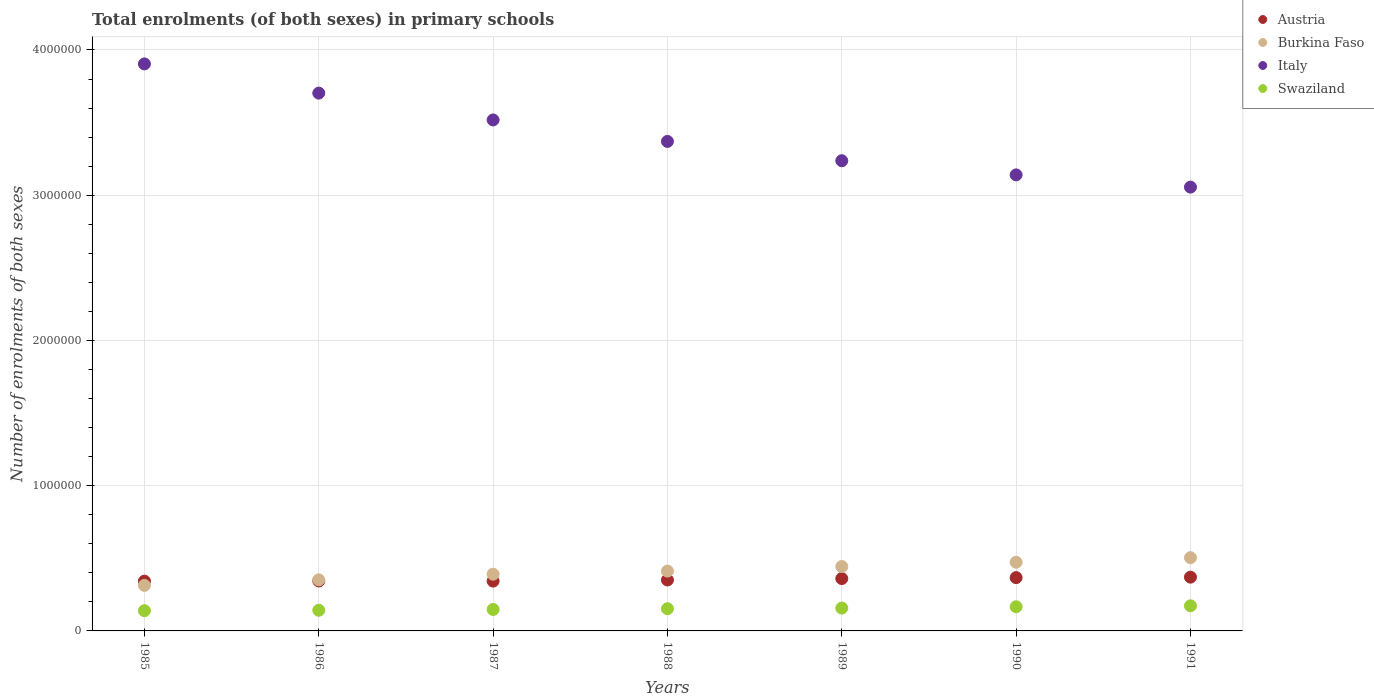Is the number of dotlines equal to the number of legend labels?
Your response must be concise. Yes. What is the number of enrolments in primary schools in Swaziland in 1986?
Make the answer very short. 1.42e+05. Across all years, what is the maximum number of enrolments in primary schools in Italy?
Your answer should be compact. 3.90e+06. Across all years, what is the minimum number of enrolments in primary schools in Swaziland?
Offer a very short reply. 1.39e+05. In which year was the number of enrolments in primary schools in Burkina Faso maximum?
Provide a short and direct response. 1991. What is the total number of enrolments in primary schools in Swaziland in the graph?
Provide a succinct answer. 1.08e+06. What is the difference between the number of enrolments in primary schools in Austria in 1989 and that in 1991?
Your response must be concise. -9668. What is the difference between the number of enrolments in primary schools in Swaziland in 1989 and the number of enrolments in primary schools in Italy in 1990?
Give a very brief answer. -2.98e+06. What is the average number of enrolments in primary schools in Italy per year?
Make the answer very short. 3.42e+06. In the year 1988, what is the difference between the number of enrolments in primary schools in Italy and number of enrolments in primary schools in Swaziland?
Provide a succinct answer. 3.22e+06. In how many years, is the number of enrolments in primary schools in Swaziland greater than 1600000?
Give a very brief answer. 0. What is the ratio of the number of enrolments in primary schools in Swaziland in 1986 to that in 1990?
Provide a short and direct response. 0.85. Is the number of enrolments in primary schools in Italy in 1986 less than that in 1988?
Your answer should be very brief. No. Is the difference between the number of enrolments in primary schools in Italy in 1985 and 1989 greater than the difference between the number of enrolments in primary schools in Swaziland in 1985 and 1989?
Provide a succinct answer. Yes. What is the difference between the highest and the second highest number of enrolments in primary schools in Italy?
Provide a succinct answer. 2.01e+05. What is the difference between the highest and the lowest number of enrolments in primary schools in Burkina Faso?
Your answer should be very brief. 1.91e+05. In how many years, is the number of enrolments in primary schools in Italy greater than the average number of enrolments in primary schools in Italy taken over all years?
Your response must be concise. 3. Is the number of enrolments in primary schools in Burkina Faso strictly greater than the number of enrolments in primary schools in Swaziland over the years?
Provide a succinct answer. Yes. Is the number of enrolments in primary schools in Italy strictly less than the number of enrolments in primary schools in Burkina Faso over the years?
Make the answer very short. No. Are the values on the major ticks of Y-axis written in scientific E-notation?
Make the answer very short. No. Does the graph contain grids?
Your answer should be compact. Yes. What is the title of the graph?
Your answer should be very brief. Total enrolments (of both sexes) in primary schools. What is the label or title of the X-axis?
Offer a very short reply. Years. What is the label or title of the Y-axis?
Provide a short and direct response. Number of enrolments of both sexes. What is the Number of enrolments of both sexes of Austria in 1985?
Keep it short and to the point. 3.43e+05. What is the Number of enrolments of both sexes of Burkina Faso in 1985?
Provide a succinct answer. 3.14e+05. What is the Number of enrolments of both sexes in Italy in 1985?
Provide a short and direct response. 3.90e+06. What is the Number of enrolments of both sexes in Swaziland in 1985?
Your answer should be compact. 1.39e+05. What is the Number of enrolments of both sexes of Austria in 1986?
Ensure brevity in your answer.  3.44e+05. What is the Number of enrolments of both sexes of Burkina Faso in 1986?
Give a very brief answer. 3.52e+05. What is the Number of enrolments of both sexes in Italy in 1986?
Offer a very short reply. 3.70e+06. What is the Number of enrolments of both sexes in Swaziland in 1986?
Your answer should be compact. 1.42e+05. What is the Number of enrolments of both sexes in Austria in 1987?
Keep it short and to the point. 3.43e+05. What is the Number of enrolments of both sexes in Burkina Faso in 1987?
Provide a short and direct response. 3.90e+05. What is the Number of enrolments of both sexes in Italy in 1987?
Provide a succinct answer. 3.52e+06. What is the Number of enrolments of both sexes of Swaziland in 1987?
Keep it short and to the point. 1.48e+05. What is the Number of enrolments of both sexes in Austria in 1988?
Your answer should be compact. 3.51e+05. What is the Number of enrolments of both sexes in Burkina Faso in 1988?
Your answer should be very brief. 4.12e+05. What is the Number of enrolments of both sexes of Italy in 1988?
Your answer should be very brief. 3.37e+06. What is the Number of enrolments of both sexes in Swaziland in 1988?
Keep it short and to the point. 1.53e+05. What is the Number of enrolments of both sexes of Austria in 1989?
Your response must be concise. 3.61e+05. What is the Number of enrolments of both sexes in Burkina Faso in 1989?
Offer a very short reply. 4.43e+05. What is the Number of enrolments of both sexes of Italy in 1989?
Provide a succinct answer. 3.24e+06. What is the Number of enrolments of both sexes of Swaziland in 1989?
Give a very brief answer. 1.57e+05. What is the Number of enrolments of both sexes in Austria in 1990?
Provide a short and direct response. 3.67e+05. What is the Number of enrolments of both sexes in Burkina Faso in 1990?
Provide a short and direct response. 4.73e+05. What is the Number of enrolments of both sexes of Italy in 1990?
Your answer should be very brief. 3.14e+06. What is the Number of enrolments of both sexes in Swaziland in 1990?
Ensure brevity in your answer.  1.66e+05. What is the Number of enrolments of both sexes in Austria in 1991?
Keep it short and to the point. 3.70e+05. What is the Number of enrolments of both sexes in Burkina Faso in 1991?
Provide a succinct answer. 5.04e+05. What is the Number of enrolments of both sexes of Italy in 1991?
Your answer should be compact. 3.06e+06. What is the Number of enrolments of both sexes of Swaziland in 1991?
Give a very brief answer. 1.73e+05. Across all years, what is the maximum Number of enrolments of both sexes in Austria?
Your answer should be very brief. 3.70e+05. Across all years, what is the maximum Number of enrolments of both sexes of Burkina Faso?
Make the answer very short. 5.04e+05. Across all years, what is the maximum Number of enrolments of both sexes of Italy?
Make the answer very short. 3.90e+06. Across all years, what is the maximum Number of enrolments of both sexes in Swaziland?
Provide a short and direct response. 1.73e+05. Across all years, what is the minimum Number of enrolments of both sexes in Austria?
Make the answer very short. 3.43e+05. Across all years, what is the minimum Number of enrolments of both sexes of Burkina Faso?
Make the answer very short. 3.14e+05. Across all years, what is the minimum Number of enrolments of both sexes in Italy?
Your answer should be very brief. 3.06e+06. Across all years, what is the minimum Number of enrolments of both sexes of Swaziland?
Make the answer very short. 1.39e+05. What is the total Number of enrolments of both sexes of Austria in the graph?
Give a very brief answer. 2.48e+06. What is the total Number of enrolments of both sexes in Burkina Faso in the graph?
Provide a succinct answer. 2.89e+06. What is the total Number of enrolments of both sexes of Italy in the graph?
Your answer should be compact. 2.39e+07. What is the total Number of enrolments of both sexes in Swaziland in the graph?
Give a very brief answer. 1.08e+06. What is the difference between the Number of enrolments of both sexes in Austria in 1985 and that in 1986?
Make the answer very short. -1044. What is the difference between the Number of enrolments of both sexes of Burkina Faso in 1985 and that in 1986?
Keep it short and to the point. -3.83e+04. What is the difference between the Number of enrolments of both sexes of Italy in 1985 and that in 1986?
Your response must be concise. 2.01e+05. What is the difference between the Number of enrolments of both sexes in Swaziland in 1985 and that in 1986?
Provide a short and direct response. -2861. What is the difference between the Number of enrolments of both sexes of Austria in 1985 and that in 1987?
Your response must be concise. -234. What is the difference between the Number of enrolments of both sexes in Burkina Faso in 1985 and that in 1987?
Your answer should be compact. -7.69e+04. What is the difference between the Number of enrolments of both sexes in Italy in 1985 and that in 1987?
Your response must be concise. 3.86e+05. What is the difference between the Number of enrolments of both sexes in Swaziland in 1985 and that in 1987?
Offer a terse response. -8398. What is the difference between the Number of enrolments of both sexes in Austria in 1985 and that in 1988?
Offer a very short reply. -7955. What is the difference between the Number of enrolments of both sexes of Burkina Faso in 1985 and that in 1988?
Provide a short and direct response. -9.84e+04. What is the difference between the Number of enrolments of both sexes of Italy in 1985 and that in 1988?
Give a very brief answer. 5.34e+05. What is the difference between the Number of enrolments of both sexes of Swaziland in 1985 and that in 1988?
Keep it short and to the point. -1.36e+04. What is the difference between the Number of enrolments of both sexes of Austria in 1985 and that in 1989?
Keep it short and to the point. -1.78e+04. What is the difference between the Number of enrolments of both sexes in Burkina Faso in 1985 and that in 1989?
Ensure brevity in your answer.  -1.30e+05. What is the difference between the Number of enrolments of both sexes in Italy in 1985 and that in 1989?
Make the answer very short. 6.67e+05. What is the difference between the Number of enrolments of both sexes in Swaziland in 1985 and that in 1989?
Your answer should be very brief. -1.80e+04. What is the difference between the Number of enrolments of both sexes of Austria in 1985 and that in 1990?
Your answer should be very brief. -2.42e+04. What is the difference between the Number of enrolments of both sexes in Burkina Faso in 1985 and that in 1990?
Offer a terse response. -1.59e+05. What is the difference between the Number of enrolments of both sexes in Italy in 1985 and that in 1990?
Keep it short and to the point. 7.64e+05. What is the difference between the Number of enrolments of both sexes of Swaziland in 1985 and that in 1990?
Your answer should be compact. -2.71e+04. What is the difference between the Number of enrolments of both sexes of Austria in 1985 and that in 1991?
Your answer should be compact. -2.74e+04. What is the difference between the Number of enrolments of both sexes in Burkina Faso in 1985 and that in 1991?
Ensure brevity in your answer.  -1.91e+05. What is the difference between the Number of enrolments of both sexes in Italy in 1985 and that in 1991?
Offer a terse response. 8.48e+05. What is the difference between the Number of enrolments of both sexes of Swaziland in 1985 and that in 1991?
Give a very brief answer. -3.36e+04. What is the difference between the Number of enrolments of both sexes of Austria in 1986 and that in 1987?
Your answer should be very brief. 810. What is the difference between the Number of enrolments of both sexes of Burkina Faso in 1986 and that in 1987?
Ensure brevity in your answer.  -3.86e+04. What is the difference between the Number of enrolments of both sexes in Italy in 1986 and that in 1987?
Your response must be concise. 1.85e+05. What is the difference between the Number of enrolments of both sexes of Swaziland in 1986 and that in 1987?
Your answer should be very brief. -5537. What is the difference between the Number of enrolments of both sexes of Austria in 1986 and that in 1988?
Make the answer very short. -6911. What is the difference between the Number of enrolments of both sexes in Burkina Faso in 1986 and that in 1988?
Your answer should be very brief. -6.01e+04. What is the difference between the Number of enrolments of both sexes in Italy in 1986 and that in 1988?
Make the answer very short. 3.33e+05. What is the difference between the Number of enrolments of both sexes in Swaziland in 1986 and that in 1988?
Keep it short and to the point. -1.07e+04. What is the difference between the Number of enrolments of both sexes in Austria in 1986 and that in 1989?
Offer a very short reply. -1.67e+04. What is the difference between the Number of enrolments of both sexes of Burkina Faso in 1986 and that in 1989?
Make the answer very short. -9.15e+04. What is the difference between the Number of enrolments of both sexes in Italy in 1986 and that in 1989?
Keep it short and to the point. 4.66e+05. What is the difference between the Number of enrolments of both sexes of Swaziland in 1986 and that in 1989?
Your answer should be compact. -1.51e+04. What is the difference between the Number of enrolments of both sexes in Austria in 1986 and that in 1990?
Offer a very short reply. -2.32e+04. What is the difference between the Number of enrolments of both sexes in Burkina Faso in 1986 and that in 1990?
Offer a very short reply. -1.21e+05. What is the difference between the Number of enrolments of both sexes in Italy in 1986 and that in 1990?
Make the answer very short. 5.63e+05. What is the difference between the Number of enrolments of both sexes of Swaziland in 1986 and that in 1990?
Give a very brief answer. -2.42e+04. What is the difference between the Number of enrolments of both sexes of Austria in 1986 and that in 1991?
Your answer should be compact. -2.64e+04. What is the difference between the Number of enrolments of both sexes of Burkina Faso in 1986 and that in 1991?
Your response must be concise. -1.53e+05. What is the difference between the Number of enrolments of both sexes in Italy in 1986 and that in 1991?
Your answer should be compact. 6.47e+05. What is the difference between the Number of enrolments of both sexes in Swaziland in 1986 and that in 1991?
Give a very brief answer. -3.07e+04. What is the difference between the Number of enrolments of both sexes of Austria in 1987 and that in 1988?
Your response must be concise. -7721. What is the difference between the Number of enrolments of both sexes of Burkina Faso in 1987 and that in 1988?
Your answer should be very brief. -2.15e+04. What is the difference between the Number of enrolments of both sexes of Italy in 1987 and that in 1988?
Give a very brief answer. 1.48e+05. What is the difference between the Number of enrolments of both sexes in Swaziland in 1987 and that in 1988?
Provide a short and direct response. -5152. What is the difference between the Number of enrolments of both sexes of Austria in 1987 and that in 1989?
Keep it short and to the point. -1.75e+04. What is the difference between the Number of enrolments of both sexes of Burkina Faso in 1987 and that in 1989?
Provide a succinct answer. -5.29e+04. What is the difference between the Number of enrolments of both sexes in Italy in 1987 and that in 1989?
Provide a short and direct response. 2.81e+05. What is the difference between the Number of enrolments of both sexes of Swaziland in 1987 and that in 1989?
Provide a short and direct response. -9602. What is the difference between the Number of enrolments of both sexes of Austria in 1987 and that in 1990?
Offer a very short reply. -2.40e+04. What is the difference between the Number of enrolments of both sexes of Burkina Faso in 1987 and that in 1990?
Make the answer very short. -8.26e+04. What is the difference between the Number of enrolments of both sexes in Italy in 1987 and that in 1990?
Provide a short and direct response. 3.78e+05. What is the difference between the Number of enrolments of both sexes of Swaziland in 1987 and that in 1990?
Offer a very short reply. -1.87e+04. What is the difference between the Number of enrolments of both sexes in Austria in 1987 and that in 1991?
Provide a succinct answer. -2.72e+04. What is the difference between the Number of enrolments of both sexes of Burkina Faso in 1987 and that in 1991?
Keep it short and to the point. -1.14e+05. What is the difference between the Number of enrolments of both sexes of Italy in 1987 and that in 1991?
Your response must be concise. 4.62e+05. What is the difference between the Number of enrolments of both sexes of Swaziland in 1987 and that in 1991?
Give a very brief answer. -2.52e+04. What is the difference between the Number of enrolments of both sexes in Austria in 1988 and that in 1989?
Provide a succinct answer. -9808. What is the difference between the Number of enrolments of both sexes in Burkina Faso in 1988 and that in 1989?
Your answer should be compact. -3.14e+04. What is the difference between the Number of enrolments of both sexes in Italy in 1988 and that in 1989?
Offer a very short reply. 1.33e+05. What is the difference between the Number of enrolments of both sexes of Swaziland in 1988 and that in 1989?
Make the answer very short. -4450. What is the difference between the Number of enrolments of both sexes of Austria in 1988 and that in 1990?
Make the answer very short. -1.63e+04. What is the difference between the Number of enrolments of both sexes of Burkina Faso in 1988 and that in 1990?
Give a very brief answer. -6.11e+04. What is the difference between the Number of enrolments of both sexes in Italy in 1988 and that in 1990?
Provide a short and direct response. 2.30e+05. What is the difference between the Number of enrolments of both sexes in Swaziland in 1988 and that in 1990?
Provide a succinct answer. -1.36e+04. What is the difference between the Number of enrolments of both sexes in Austria in 1988 and that in 1991?
Keep it short and to the point. -1.95e+04. What is the difference between the Number of enrolments of both sexes of Burkina Faso in 1988 and that in 1991?
Your answer should be compact. -9.25e+04. What is the difference between the Number of enrolments of both sexes in Italy in 1988 and that in 1991?
Your answer should be very brief. 3.15e+05. What is the difference between the Number of enrolments of both sexes of Swaziland in 1988 and that in 1991?
Provide a short and direct response. -2.00e+04. What is the difference between the Number of enrolments of both sexes of Austria in 1989 and that in 1990?
Offer a very short reply. -6464. What is the difference between the Number of enrolments of both sexes of Burkina Faso in 1989 and that in 1990?
Offer a very short reply. -2.97e+04. What is the difference between the Number of enrolments of both sexes of Italy in 1989 and that in 1990?
Provide a succinct answer. 9.75e+04. What is the difference between the Number of enrolments of both sexes of Swaziland in 1989 and that in 1990?
Your answer should be very brief. -9109. What is the difference between the Number of enrolments of both sexes of Austria in 1989 and that in 1991?
Keep it short and to the point. -9668. What is the difference between the Number of enrolments of both sexes in Burkina Faso in 1989 and that in 1991?
Give a very brief answer. -6.11e+04. What is the difference between the Number of enrolments of both sexes in Italy in 1989 and that in 1991?
Your answer should be compact. 1.82e+05. What is the difference between the Number of enrolments of both sexes of Swaziland in 1989 and that in 1991?
Ensure brevity in your answer.  -1.56e+04. What is the difference between the Number of enrolments of both sexes in Austria in 1990 and that in 1991?
Offer a terse response. -3204. What is the difference between the Number of enrolments of both sexes of Burkina Faso in 1990 and that in 1991?
Offer a terse response. -3.14e+04. What is the difference between the Number of enrolments of both sexes of Italy in 1990 and that in 1991?
Ensure brevity in your answer.  8.42e+04. What is the difference between the Number of enrolments of both sexes of Swaziland in 1990 and that in 1991?
Keep it short and to the point. -6454. What is the difference between the Number of enrolments of both sexes of Austria in 1985 and the Number of enrolments of both sexes of Burkina Faso in 1986?
Your response must be concise. -9028. What is the difference between the Number of enrolments of both sexes of Austria in 1985 and the Number of enrolments of both sexes of Italy in 1986?
Give a very brief answer. -3.36e+06. What is the difference between the Number of enrolments of both sexes in Austria in 1985 and the Number of enrolments of both sexes in Swaziland in 1986?
Offer a terse response. 2.01e+05. What is the difference between the Number of enrolments of both sexes of Burkina Faso in 1985 and the Number of enrolments of both sexes of Italy in 1986?
Offer a very short reply. -3.39e+06. What is the difference between the Number of enrolments of both sexes of Burkina Faso in 1985 and the Number of enrolments of both sexes of Swaziland in 1986?
Provide a succinct answer. 1.71e+05. What is the difference between the Number of enrolments of both sexes in Italy in 1985 and the Number of enrolments of both sexes in Swaziland in 1986?
Your response must be concise. 3.76e+06. What is the difference between the Number of enrolments of both sexes of Austria in 1985 and the Number of enrolments of both sexes of Burkina Faso in 1987?
Your response must be concise. -4.76e+04. What is the difference between the Number of enrolments of both sexes of Austria in 1985 and the Number of enrolments of both sexes of Italy in 1987?
Your response must be concise. -3.18e+06. What is the difference between the Number of enrolments of both sexes in Austria in 1985 and the Number of enrolments of both sexes in Swaziland in 1987?
Give a very brief answer. 1.95e+05. What is the difference between the Number of enrolments of both sexes in Burkina Faso in 1985 and the Number of enrolments of both sexes in Italy in 1987?
Provide a short and direct response. -3.20e+06. What is the difference between the Number of enrolments of both sexes in Burkina Faso in 1985 and the Number of enrolments of both sexes in Swaziland in 1987?
Your answer should be compact. 1.66e+05. What is the difference between the Number of enrolments of both sexes in Italy in 1985 and the Number of enrolments of both sexes in Swaziland in 1987?
Your response must be concise. 3.76e+06. What is the difference between the Number of enrolments of both sexes of Austria in 1985 and the Number of enrolments of both sexes of Burkina Faso in 1988?
Your answer should be compact. -6.91e+04. What is the difference between the Number of enrolments of both sexes of Austria in 1985 and the Number of enrolments of both sexes of Italy in 1988?
Offer a very short reply. -3.03e+06. What is the difference between the Number of enrolments of both sexes in Austria in 1985 and the Number of enrolments of both sexes in Swaziland in 1988?
Offer a very short reply. 1.90e+05. What is the difference between the Number of enrolments of both sexes in Burkina Faso in 1985 and the Number of enrolments of both sexes in Italy in 1988?
Give a very brief answer. -3.06e+06. What is the difference between the Number of enrolments of both sexes in Burkina Faso in 1985 and the Number of enrolments of both sexes in Swaziland in 1988?
Provide a short and direct response. 1.61e+05. What is the difference between the Number of enrolments of both sexes in Italy in 1985 and the Number of enrolments of both sexes in Swaziland in 1988?
Offer a terse response. 3.75e+06. What is the difference between the Number of enrolments of both sexes of Austria in 1985 and the Number of enrolments of both sexes of Burkina Faso in 1989?
Give a very brief answer. -1.01e+05. What is the difference between the Number of enrolments of both sexes in Austria in 1985 and the Number of enrolments of both sexes in Italy in 1989?
Offer a terse response. -2.89e+06. What is the difference between the Number of enrolments of both sexes in Austria in 1985 and the Number of enrolments of both sexes in Swaziland in 1989?
Offer a very short reply. 1.85e+05. What is the difference between the Number of enrolments of both sexes of Burkina Faso in 1985 and the Number of enrolments of both sexes of Italy in 1989?
Provide a succinct answer. -2.92e+06. What is the difference between the Number of enrolments of both sexes of Burkina Faso in 1985 and the Number of enrolments of both sexes of Swaziland in 1989?
Provide a short and direct response. 1.56e+05. What is the difference between the Number of enrolments of both sexes of Italy in 1985 and the Number of enrolments of both sexes of Swaziland in 1989?
Give a very brief answer. 3.75e+06. What is the difference between the Number of enrolments of both sexes in Austria in 1985 and the Number of enrolments of both sexes in Burkina Faso in 1990?
Your answer should be very brief. -1.30e+05. What is the difference between the Number of enrolments of both sexes in Austria in 1985 and the Number of enrolments of both sexes in Italy in 1990?
Ensure brevity in your answer.  -2.80e+06. What is the difference between the Number of enrolments of both sexes in Austria in 1985 and the Number of enrolments of both sexes in Swaziland in 1990?
Keep it short and to the point. 1.76e+05. What is the difference between the Number of enrolments of both sexes of Burkina Faso in 1985 and the Number of enrolments of both sexes of Italy in 1990?
Keep it short and to the point. -2.83e+06. What is the difference between the Number of enrolments of both sexes in Burkina Faso in 1985 and the Number of enrolments of both sexes in Swaziland in 1990?
Your answer should be very brief. 1.47e+05. What is the difference between the Number of enrolments of both sexes in Italy in 1985 and the Number of enrolments of both sexes in Swaziland in 1990?
Provide a short and direct response. 3.74e+06. What is the difference between the Number of enrolments of both sexes in Austria in 1985 and the Number of enrolments of both sexes in Burkina Faso in 1991?
Your answer should be very brief. -1.62e+05. What is the difference between the Number of enrolments of both sexes in Austria in 1985 and the Number of enrolments of both sexes in Italy in 1991?
Give a very brief answer. -2.71e+06. What is the difference between the Number of enrolments of both sexes of Austria in 1985 and the Number of enrolments of both sexes of Swaziland in 1991?
Keep it short and to the point. 1.70e+05. What is the difference between the Number of enrolments of both sexes of Burkina Faso in 1985 and the Number of enrolments of both sexes of Italy in 1991?
Ensure brevity in your answer.  -2.74e+06. What is the difference between the Number of enrolments of both sexes in Burkina Faso in 1985 and the Number of enrolments of both sexes in Swaziland in 1991?
Keep it short and to the point. 1.41e+05. What is the difference between the Number of enrolments of both sexes of Italy in 1985 and the Number of enrolments of both sexes of Swaziland in 1991?
Give a very brief answer. 3.73e+06. What is the difference between the Number of enrolments of both sexes of Austria in 1986 and the Number of enrolments of both sexes of Burkina Faso in 1987?
Ensure brevity in your answer.  -4.66e+04. What is the difference between the Number of enrolments of both sexes of Austria in 1986 and the Number of enrolments of both sexes of Italy in 1987?
Keep it short and to the point. -3.17e+06. What is the difference between the Number of enrolments of both sexes of Austria in 1986 and the Number of enrolments of both sexes of Swaziland in 1987?
Keep it short and to the point. 1.96e+05. What is the difference between the Number of enrolments of both sexes in Burkina Faso in 1986 and the Number of enrolments of both sexes in Italy in 1987?
Make the answer very short. -3.17e+06. What is the difference between the Number of enrolments of both sexes in Burkina Faso in 1986 and the Number of enrolments of both sexes in Swaziland in 1987?
Provide a short and direct response. 2.04e+05. What is the difference between the Number of enrolments of both sexes of Italy in 1986 and the Number of enrolments of both sexes of Swaziland in 1987?
Give a very brief answer. 3.56e+06. What is the difference between the Number of enrolments of both sexes in Austria in 1986 and the Number of enrolments of both sexes in Burkina Faso in 1988?
Ensure brevity in your answer.  -6.81e+04. What is the difference between the Number of enrolments of both sexes in Austria in 1986 and the Number of enrolments of both sexes in Italy in 1988?
Offer a terse response. -3.03e+06. What is the difference between the Number of enrolments of both sexes in Austria in 1986 and the Number of enrolments of both sexes in Swaziland in 1988?
Provide a short and direct response. 1.91e+05. What is the difference between the Number of enrolments of both sexes of Burkina Faso in 1986 and the Number of enrolments of both sexes of Italy in 1988?
Give a very brief answer. -3.02e+06. What is the difference between the Number of enrolments of both sexes in Burkina Faso in 1986 and the Number of enrolments of both sexes in Swaziland in 1988?
Keep it short and to the point. 1.99e+05. What is the difference between the Number of enrolments of both sexes in Italy in 1986 and the Number of enrolments of both sexes in Swaziland in 1988?
Give a very brief answer. 3.55e+06. What is the difference between the Number of enrolments of both sexes of Austria in 1986 and the Number of enrolments of both sexes of Burkina Faso in 1989?
Your response must be concise. -9.95e+04. What is the difference between the Number of enrolments of both sexes in Austria in 1986 and the Number of enrolments of both sexes in Italy in 1989?
Provide a short and direct response. -2.89e+06. What is the difference between the Number of enrolments of both sexes in Austria in 1986 and the Number of enrolments of both sexes in Swaziland in 1989?
Make the answer very short. 1.86e+05. What is the difference between the Number of enrolments of both sexes in Burkina Faso in 1986 and the Number of enrolments of both sexes in Italy in 1989?
Ensure brevity in your answer.  -2.89e+06. What is the difference between the Number of enrolments of both sexes in Burkina Faso in 1986 and the Number of enrolments of both sexes in Swaziland in 1989?
Offer a very short reply. 1.94e+05. What is the difference between the Number of enrolments of both sexes in Italy in 1986 and the Number of enrolments of both sexes in Swaziland in 1989?
Offer a very short reply. 3.55e+06. What is the difference between the Number of enrolments of both sexes of Austria in 1986 and the Number of enrolments of both sexes of Burkina Faso in 1990?
Give a very brief answer. -1.29e+05. What is the difference between the Number of enrolments of both sexes of Austria in 1986 and the Number of enrolments of both sexes of Italy in 1990?
Offer a terse response. -2.80e+06. What is the difference between the Number of enrolments of both sexes in Austria in 1986 and the Number of enrolments of both sexes in Swaziland in 1990?
Ensure brevity in your answer.  1.77e+05. What is the difference between the Number of enrolments of both sexes of Burkina Faso in 1986 and the Number of enrolments of both sexes of Italy in 1990?
Your answer should be compact. -2.79e+06. What is the difference between the Number of enrolments of both sexes in Burkina Faso in 1986 and the Number of enrolments of both sexes in Swaziland in 1990?
Offer a very short reply. 1.85e+05. What is the difference between the Number of enrolments of both sexes in Italy in 1986 and the Number of enrolments of both sexes in Swaziland in 1990?
Keep it short and to the point. 3.54e+06. What is the difference between the Number of enrolments of both sexes of Austria in 1986 and the Number of enrolments of both sexes of Burkina Faso in 1991?
Your answer should be very brief. -1.61e+05. What is the difference between the Number of enrolments of both sexes in Austria in 1986 and the Number of enrolments of both sexes in Italy in 1991?
Offer a terse response. -2.71e+06. What is the difference between the Number of enrolments of both sexes of Austria in 1986 and the Number of enrolments of both sexes of Swaziland in 1991?
Give a very brief answer. 1.71e+05. What is the difference between the Number of enrolments of both sexes in Burkina Faso in 1986 and the Number of enrolments of both sexes in Italy in 1991?
Provide a succinct answer. -2.70e+06. What is the difference between the Number of enrolments of both sexes in Burkina Faso in 1986 and the Number of enrolments of both sexes in Swaziland in 1991?
Ensure brevity in your answer.  1.79e+05. What is the difference between the Number of enrolments of both sexes of Italy in 1986 and the Number of enrolments of both sexes of Swaziland in 1991?
Provide a succinct answer. 3.53e+06. What is the difference between the Number of enrolments of both sexes of Austria in 1987 and the Number of enrolments of both sexes of Burkina Faso in 1988?
Ensure brevity in your answer.  -6.89e+04. What is the difference between the Number of enrolments of both sexes of Austria in 1987 and the Number of enrolments of both sexes of Italy in 1988?
Your response must be concise. -3.03e+06. What is the difference between the Number of enrolments of both sexes of Austria in 1987 and the Number of enrolments of both sexes of Swaziland in 1988?
Give a very brief answer. 1.90e+05. What is the difference between the Number of enrolments of both sexes of Burkina Faso in 1987 and the Number of enrolments of both sexes of Italy in 1988?
Give a very brief answer. -2.98e+06. What is the difference between the Number of enrolments of both sexes in Burkina Faso in 1987 and the Number of enrolments of both sexes in Swaziland in 1988?
Ensure brevity in your answer.  2.38e+05. What is the difference between the Number of enrolments of both sexes in Italy in 1987 and the Number of enrolments of both sexes in Swaziland in 1988?
Ensure brevity in your answer.  3.37e+06. What is the difference between the Number of enrolments of both sexes of Austria in 1987 and the Number of enrolments of both sexes of Burkina Faso in 1989?
Keep it short and to the point. -1.00e+05. What is the difference between the Number of enrolments of both sexes of Austria in 1987 and the Number of enrolments of both sexes of Italy in 1989?
Give a very brief answer. -2.89e+06. What is the difference between the Number of enrolments of both sexes in Austria in 1987 and the Number of enrolments of both sexes in Swaziland in 1989?
Your answer should be compact. 1.86e+05. What is the difference between the Number of enrolments of both sexes in Burkina Faso in 1987 and the Number of enrolments of both sexes in Italy in 1989?
Ensure brevity in your answer.  -2.85e+06. What is the difference between the Number of enrolments of both sexes in Burkina Faso in 1987 and the Number of enrolments of both sexes in Swaziland in 1989?
Provide a short and direct response. 2.33e+05. What is the difference between the Number of enrolments of both sexes of Italy in 1987 and the Number of enrolments of both sexes of Swaziland in 1989?
Make the answer very short. 3.36e+06. What is the difference between the Number of enrolments of both sexes of Austria in 1987 and the Number of enrolments of both sexes of Burkina Faso in 1990?
Your answer should be compact. -1.30e+05. What is the difference between the Number of enrolments of both sexes of Austria in 1987 and the Number of enrolments of both sexes of Italy in 1990?
Give a very brief answer. -2.80e+06. What is the difference between the Number of enrolments of both sexes in Austria in 1987 and the Number of enrolments of both sexes in Swaziland in 1990?
Your answer should be very brief. 1.77e+05. What is the difference between the Number of enrolments of both sexes of Burkina Faso in 1987 and the Number of enrolments of both sexes of Italy in 1990?
Make the answer very short. -2.75e+06. What is the difference between the Number of enrolments of both sexes in Burkina Faso in 1987 and the Number of enrolments of both sexes in Swaziland in 1990?
Ensure brevity in your answer.  2.24e+05. What is the difference between the Number of enrolments of both sexes in Italy in 1987 and the Number of enrolments of both sexes in Swaziland in 1990?
Your answer should be very brief. 3.35e+06. What is the difference between the Number of enrolments of both sexes of Austria in 1987 and the Number of enrolments of both sexes of Burkina Faso in 1991?
Offer a very short reply. -1.61e+05. What is the difference between the Number of enrolments of both sexes of Austria in 1987 and the Number of enrolments of both sexes of Italy in 1991?
Your answer should be very brief. -2.71e+06. What is the difference between the Number of enrolments of both sexes in Austria in 1987 and the Number of enrolments of both sexes in Swaziland in 1991?
Your answer should be compact. 1.70e+05. What is the difference between the Number of enrolments of both sexes of Burkina Faso in 1987 and the Number of enrolments of both sexes of Italy in 1991?
Your response must be concise. -2.67e+06. What is the difference between the Number of enrolments of both sexes of Burkina Faso in 1987 and the Number of enrolments of both sexes of Swaziland in 1991?
Your answer should be compact. 2.18e+05. What is the difference between the Number of enrolments of both sexes of Italy in 1987 and the Number of enrolments of both sexes of Swaziland in 1991?
Give a very brief answer. 3.35e+06. What is the difference between the Number of enrolments of both sexes in Austria in 1988 and the Number of enrolments of both sexes in Burkina Faso in 1989?
Your response must be concise. -9.26e+04. What is the difference between the Number of enrolments of both sexes of Austria in 1988 and the Number of enrolments of both sexes of Italy in 1989?
Make the answer very short. -2.89e+06. What is the difference between the Number of enrolments of both sexes in Austria in 1988 and the Number of enrolments of both sexes in Swaziland in 1989?
Your answer should be compact. 1.93e+05. What is the difference between the Number of enrolments of both sexes in Burkina Faso in 1988 and the Number of enrolments of both sexes in Italy in 1989?
Offer a very short reply. -2.83e+06. What is the difference between the Number of enrolments of both sexes of Burkina Faso in 1988 and the Number of enrolments of both sexes of Swaziland in 1989?
Offer a terse response. 2.55e+05. What is the difference between the Number of enrolments of both sexes of Italy in 1988 and the Number of enrolments of both sexes of Swaziland in 1989?
Ensure brevity in your answer.  3.21e+06. What is the difference between the Number of enrolments of both sexes in Austria in 1988 and the Number of enrolments of both sexes in Burkina Faso in 1990?
Keep it short and to the point. -1.22e+05. What is the difference between the Number of enrolments of both sexes of Austria in 1988 and the Number of enrolments of both sexes of Italy in 1990?
Give a very brief answer. -2.79e+06. What is the difference between the Number of enrolments of both sexes of Austria in 1988 and the Number of enrolments of both sexes of Swaziland in 1990?
Your response must be concise. 1.84e+05. What is the difference between the Number of enrolments of both sexes of Burkina Faso in 1988 and the Number of enrolments of both sexes of Italy in 1990?
Keep it short and to the point. -2.73e+06. What is the difference between the Number of enrolments of both sexes of Burkina Faso in 1988 and the Number of enrolments of both sexes of Swaziland in 1990?
Your answer should be very brief. 2.45e+05. What is the difference between the Number of enrolments of both sexes in Italy in 1988 and the Number of enrolments of both sexes in Swaziland in 1990?
Make the answer very short. 3.20e+06. What is the difference between the Number of enrolments of both sexes in Austria in 1988 and the Number of enrolments of both sexes in Burkina Faso in 1991?
Offer a terse response. -1.54e+05. What is the difference between the Number of enrolments of both sexes in Austria in 1988 and the Number of enrolments of both sexes in Italy in 1991?
Provide a short and direct response. -2.71e+06. What is the difference between the Number of enrolments of both sexes of Austria in 1988 and the Number of enrolments of both sexes of Swaziland in 1991?
Your answer should be very brief. 1.78e+05. What is the difference between the Number of enrolments of both sexes of Burkina Faso in 1988 and the Number of enrolments of both sexes of Italy in 1991?
Provide a short and direct response. -2.64e+06. What is the difference between the Number of enrolments of both sexes in Burkina Faso in 1988 and the Number of enrolments of both sexes in Swaziland in 1991?
Your answer should be compact. 2.39e+05. What is the difference between the Number of enrolments of both sexes in Italy in 1988 and the Number of enrolments of both sexes in Swaziland in 1991?
Your answer should be very brief. 3.20e+06. What is the difference between the Number of enrolments of both sexes of Austria in 1989 and the Number of enrolments of both sexes of Burkina Faso in 1990?
Give a very brief answer. -1.12e+05. What is the difference between the Number of enrolments of both sexes in Austria in 1989 and the Number of enrolments of both sexes in Italy in 1990?
Your response must be concise. -2.78e+06. What is the difference between the Number of enrolments of both sexes in Austria in 1989 and the Number of enrolments of both sexes in Swaziland in 1990?
Keep it short and to the point. 1.94e+05. What is the difference between the Number of enrolments of both sexes of Burkina Faso in 1989 and the Number of enrolments of both sexes of Italy in 1990?
Your answer should be compact. -2.70e+06. What is the difference between the Number of enrolments of both sexes in Burkina Faso in 1989 and the Number of enrolments of both sexes in Swaziland in 1990?
Offer a terse response. 2.77e+05. What is the difference between the Number of enrolments of both sexes of Italy in 1989 and the Number of enrolments of both sexes of Swaziland in 1990?
Offer a terse response. 3.07e+06. What is the difference between the Number of enrolments of both sexes in Austria in 1989 and the Number of enrolments of both sexes in Burkina Faso in 1991?
Your answer should be compact. -1.44e+05. What is the difference between the Number of enrolments of both sexes in Austria in 1989 and the Number of enrolments of both sexes in Italy in 1991?
Provide a succinct answer. -2.70e+06. What is the difference between the Number of enrolments of both sexes in Austria in 1989 and the Number of enrolments of both sexes in Swaziland in 1991?
Provide a succinct answer. 1.88e+05. What is the difference between the Number of enrolments of both sexes of Burkina Faso in 1989 and the Number of enrolments of both sexes of Italy in 1991?
Make the answer very short. -2.61e+06. What is the difference between the Number of enrolments of both sexes in Burkina Faso in 1989 and the Number of enrolments of both sexes in Swaziland in 1991?
Your answer should be very brief. 2.70e+05. What is the difference between the Number of enrolments of both sexes in Italy in 1989 and the Number of enrolments of both sexes in Swaziland in 1991?
Provide a short and direct response. 3.06e+06. What is the difference between the Number of enrolments of both sexes of Austria in 1990 and the Number of enrolments of both sexes of Burkina Faso in 1991?
Your answer should be very brief. -1.37e+05. What is the difference between the Number of enrolments of both sexes in Austria in 1990 and the Number of enrolments of both sexes in Italy in 1991?
Keep it short and to the point. -2.69e+06. What is the difference between the Number of enrolments of both sexes in Austria in 1990 and the Number of enrolments of both sexes in Swaziland in 1991?
Your response must be concise. 1.94e+05. What is the difference between the Number of enrolments of both sexes in Burkina Faso in 1990 and the Number of enrolments of both sexes in Italy in 1991?
Keep it short and to the point. -2.58e+06. What is the difference between the Number of enrolments of both sexes of Burkina Faso in 1990 and the Number of enrolments of both sexes of Swaziland in 1991?
Keep it short and to the point. 3.00e+05. What is the difference between the Number of enrolments of both sexes of Italy in 1990 and the Number of enrolments of both sexes of Swaziland in 1991?
Offer a very short reply. 2.97e+06. What is the average Number of enrolments of both sexes in Austria per year?
Keep it short and to the point. 3.54e+05. What is the average Number of enrolments of both sexes in Burkina Faso per year?
Ensure brevity in your answer.  4.13e+05. What is the average Number of enrolments of both sexes of Italy per year?
Provide a short and direct response. 3.42e+06. What is the average Number of enrolments of both sexes of Swaziland per year?
Provide a succinct answer. 1.54e+05. In the year 1985, what is the difference between the Number of enrolments of both sexes in Austria and Number of enrolments of both sexes in Burkina Faso?
Give a very brief answer. 2.93e+04. In the year 1985, what is the difference between the Number of enrolments of both sexes of Austria and Number of enrolments of both sexes of Italy?
Your answer should be very brief. -3.56e+06. In the year 1985, what is the difference between the Number of enrolments of both sexes in Austria and Number of enrolments of both sexes in Swaziland?
Your response must be concise. 2.03e+05. In the year 1985, what is the difference between the Number of enrolments of both sexes of Burkina Faso and Number of enrolments of both sexes of Italy?
Provide a succinct answer. -3.59e+06. In the year 1985, what is the difference between the Number of enrolments of both sexes of Burkina Faso and Number of enrolments of both sexes of Swaziland?
Ensure brevity in your answer.  1.74e+05. In the year 1985, what is the difference between the Number of enrolments of both sexes of Italy and Number of enrolments of both sexes of Swaziland?
Your answer should be very brief. 3.76e+06. In the year 1986, what is the difference between the Number of enrolments of both sexes of Austria and Number of enrolments of both sexes of Burkina Faso?
Offer a very short reply. -7984. In the year 1986, what is the difference between the Number of enrolments of both sexes of Austria and Number of enrolments of both sexes of Italy?
Provide a short and direct response. -3.36e+06. In the year 1986, what is the difference between the Number of enrolments of both sexes of Austria and Number of enrolments of both sexes of Swaziland?
Your response must be concise. 2.02e+05. In the year 1986, what is the difference between the Number of enrolments of both sexes of Burkina Faso and Number of enrolments of both sexes of Italy?
Offer a very short reply. -3.35e+06. In the year 1986, what is the difference between the Number of enrolments of both sexes in Burkina Faso and Number of enrolments of both sexes in Swaziland?
Your response must be concise. 2.10e+05. In the year 1986, what is the difference between the Number of enrolments of both sexes in Italy and Number of enrolments of both sexes in Swaziland?
Your answer should be compact. 3.56e+06. In the year 1987, what is the difference between the Number of enrolments of both sexes in Austria and Number of enrolments of both sexes in Burkina Faso?
Make the answer very short. -4.74e+04. In the year 1987, what is the difference between the Number of enrolments of both sexes in Austria and Number of enrolments of both sexes in Italy?
Ensure brevity in your answer.  -3.18e+06. In the year 1987, what is the difference between the Number of enrolments of both sexes of Austria and Number of enrolments of both sexes of Swaziland?
Your answer should be compact. 1.95e+05. In the year 1987, what is the difference between the Number of enrolments of both sexes in Burkina Faso and Number of enrolments of both sexes in Italy?
Make the answer very short. -3.13e+06. In the year 1987, what is the difference between the Number of enrolments of both sexes in Burkina Faso and Number of enrolments of both sexes in Swaziland?
Ensure brevity in your answer.  2.43e+05. In the year 1987, what is the difference between the Number of enrolments of both sexes in Italy and Number of enrolments of both sexes in Swaziland?
Your answer should be compact. 3.37e+06. In the year 1988, what is the difference between the Number of enrolments of both sexes in Austria and Number of enrolments of both sexes in Burkina Faso?
Your response must be concise. -6.12e+04. In the year 1988, what is the difference between the Number of enrolments of both sexes of Austria and Number of enrolments of both sexes of Italy?
Offer a very short reply. -3.02e+06. In the year 1988, what is the difference between the Number of enrolments of both sexes in Austria and Number of enrolments of both sexes in Swaziland?
Your response must be concise. 1.98e+05. In the year 1988, what is the difference between the Number of enrolments of both sexes in Burkina Faso and Number of enrolments of both sexes in Italy?
Your answer should be compact. -2.96e+06. In the year 1988, what is the difference between the Number of enrolments of both sexes of Burkina Faso and Number of enrolments of both sexes of Swaziland?
Keep it short and to the point. 2.59e+05. In the year 1988, what is the difference between the Number of enrolments of both sexes in Italy and Number of enrolments of both sexes in Swaziland?
Your response must be concise. 3.22e+06. In the year 1989, what is the difference between the Number of enrolments of both sexes of Austria and Number of enrolments of both sexes of Burkina Faso?
Your answer should be very brief. -8.28e+04. In the year 1989, what is the difference between the Number of enrolments of both sexes of Austria and Number of enrolments of both sexes of Italy?
Your answer should be very brief. -2.88e+06. In the year 1989, what is the difference between the Number of enrolments of both sexes of Austria and Number of enrolments of both sexes of Swaziland?
Offer a very short reply. 2.03e+05. In the year 1989, what is the difference between the Number of enrolments of both sexes in Burkina Faso and Number of enrolments of both sexes in Italy?
Your answer should be very brief. -2.79e+06. In the year 1989, what is the difference between the Number of enrolments of both sexes in Burkina Faso and Number of enrolments of both sexes in Swaziland?
Your answer should be very brief. 2.86e+05. In the year 1989, what is the difference between the Number of enrolments of both sexes in Italy and Number of enrolments of both sexes in Swaziland?
Make the answer very short. 3.08e+06. In the year 1990, what is the difference between the Number of enrolments of both sexes in Austria and Number of enrolments of both sexes in Burkina Faso?
Provide a succinct answer. -1.06e+05. In the year 1990, what is the difference between the Number of enrolments of both sexes in Austria and Number of enrolments of both sexes in Italy?
Give a very brief answer. -2.77e+06. In the year 1990, what is the difference between the Number of enrolments of both sexes of Austria and Number of enrolments of both sexes of Swaziland?
Make the answer very short. 2.01e+05. In the year 1990, what is the difference between the Number of enrolments of both sexes of Burkina Faso and Number of enrolments of both sexes of Italy?
Keep it short and to the point. -2.67e+06. In the year 1990, what is the difference between the Number of enrolments of both sexes of Burkina Faso and Number of enrolments of both sexes of Swaziland?
Your response must be concise. 3.07e+05. In the year 1990, what is the difference between the Number of enrolments of both sexes of Italy and Number of enrolments of both sexes of Swaziland?
Provide a succinct answer. 2.97e+06. In the year 1991, what is the difference between the Number of enrolments of both sexes in Austria and Number of enrolments of both sexes in Burkina Faso?
Keep it short and to the point. -1.34e+05. In the year 1991, what is the difference between the Number of enrolments of both sexes of Austria and Number of enrolments of both sexes of Italy?
Provide a succinct answer. -2.69e+06. In the year 1991, what is the difference between the Number of enrolments of both sexes in Austria and Number of enrolments of both sexes in Swaziland?
Make the answer very short. 1.97e+05. In the year 1991, what is the difference between the Number of enrolments of both sexes in Burkina Faso and Number of enrolments of both sexes in Italy?
Make the answer very short. -2.55e+06. In the year 1991, what is the difference between the Number of enrolments of both sexes in Burkina Faso and Number of enrolments of both sexes in Swaziland?
Make the answer very short. 3.32e+05. In the year 1991, what is the difference between the Number of enrolments of both sexes in Italy and Number of enrolments of both sexes in Swaziland?
Your answer should be compact. 2.88e+06. What is the ratio of the Number of enrolments of both sexes of Burkina Faso in 1985 to that in 1986?
Offer a terse response. 0.89. What is the ratio of the Number of enrolments of both sexes in Italy in 1985 to that in 1986?
Ensure brevity in your answer.  1.05. What is the ratio of the Number of enrolments of both sexes in Swaziland in 1985 to that in 1986?
Offer a very short reply. 0.98. What is the ratio of the Number of enrolments of both sexes in Austria in 1985 to that in 1987?
Provide a short and direct response. 1. What is the ratio of the Number of enrolments of both sexes in Burkina Faso in 1985 to that in 1987?
Offer a very short reply. 0.8. What is the ratio of the Number of enrolments of both sexes in Italy in 1985 to that in 1987?
Your answer should be very brief. 1.11. What is the ratio of the Number of enrolments of both sexes in Swaziland in 1985 to that in 1987?
Offer a terse response. 0.94. What is the ratio of the Number of enrolments of both sexes in Austria in 1985 to that in 1988?
Ensure brevity in your answer.  0.98. What is the ratio of the Number of enrolments of both sexes of Burkina Faso in 1985 to that in 1988?
Keep it short and to the point. 0.76. What is the ratio of the Number of enrolments of both sexes of Italy in 1985 to that in 1988?
Provide a short and direct response. 1.16. What is the ratio of the Number of enrolments of both sexes of Swaziland in 1985 to that in 1988?
Offer a terse response. 0.91. What is the ratio of the Number of enrolments of both sexes in Austria in 1985 to that in 1989?
Provide a succinct answer. 0.95. What is the ratio of the Number of enrolments of both sexes of Burkina Faso in 1985 to that in 1989?
Your response must be concise. 0.71. What is the ratio of the Number of enrolments of both sexes of Italy in 1985 to that in 1989?
Offer a terse response. 1.21. What is the ratio of the Number of enrolments of both sexes of Swaziland in 1985 to that in 1989?
Your response must be concise. 0.89. What is the ratio of the Number of enrolments of both sexes in Austria in 1985 to that in 1990?
Your answer should be compact. 0.93. What is the ratio of the Number of enrolments of both sexes in Burkina Faso in 1985 to that in 1990?
Make the answer very short. 0.66. What is the ratio of the Number of enrolments of both sexes of Italy in 1985 to that in 1990?
Ensure brevity in your answer.  1.24. What is the ratio of the Number of enrolments of both sexes of Swaziland in 1985 to that in 1990?
Your answer should be compact. 0.84. What is the ratio of the Number of enrolments of both sexes of Austria in 1985 to that in 1991?
Make the answer very short. 0.93. What is the ratio of the Number of enrolments of both sexes in Burkina Faso in 1985 to that in 1991?
Offer a very short reply. 0.62. What is the ratio of the Number of enrolments of both sexes in Italy in 1985 to that in 1991?
Provide a succinct answer. 1.28. What is the ratio of the Number of enrolments of both sexes in Swaziland in 1985 to that in 1991?
Offer a very short reply. 0.81. What is the ratio of the Number of enrolments of both sexes of Burkina Faso in 1986 to that in 1987?
Offer a terse response. 0.9. What is the ratio of the Number of enrolments of both sexes of Italy in 1986 to that in 1987?
Give a very brief answer. 1.05. What is the ratio of the Number of enrolments of both sexes of Swaziland in 1986 to that in 1987?
Keep it short and to the point. 0.96. What is the ratio of the Number of enrolments of both sexes of Austria in 1986 to that in 1988?
Give a very brief answer. 0.98. What is the ratio of the Number of enrolments of both sexes of Burkina Faso in 1986 to that in 1988?
Make the answer very short. 0.85. What is the ratio of the Number of enrolments of both sexes in Italy in 1986 to that in 1988?
Your answer should be very brief. 1.1. What is the ratio of the Number of enrolments of both sexes in Swaziland in 1986 to that in 1988?
Offer a terse response. 0.93. What is the ratio of the Number of enrolments of both sexes in Austria in 1986 to that in 1989?
Your answer should be very brief. 0.95. What is the ratio of the Number of enrolments of both sexes in Burkina Faso in 1986 to that in 1989?
Keep it short and to the point. 0.79. What is the ratio of the Number of enrolments of both sexes of Italy in 1986 to that in 1989?
Keep it short and to the point. 1.14. What is the ratio of the Number of enrolments of both sexes of Swaziland in 1986 to that in 1989?
Offer a very short reply. 0.9. What is the ratio of the Number of enrolments of both sexes of Austria in 1986 to that in 1990?
Provide a short and direct response. 0.94. What is the ratio of the Number of enrolments of both sexes in Burkina Faso in 1986 to that in 1990?
Your response must be concise. 0.74. What is the ratio of the Number of enrolments of both sexes in Italy in 1986 to that in 1990?
Your response must be concise. 1.18. What is the ratio of the Number of enrolments of both sexes in Swaziland in 1986 to that in 1990?
Your answer should be very brief. 0.85. What is the ratio of the Number of enrolments of both sexes of Austria in 1986 to that in 1991?
Give a very brief answer. 0.93. What is the ratio of the Number of enrolments of both sexes in Burkina Faso in 1986 to that in 1991?
Keep it short and to the point. 0.7. What is the ratio of the Number of enrolments of both sexes in Italy in 1986 to that in 1991?
Offer a terse response. 1.21. What is the ratio of the Number of enrolments of both sexes of Swaziland in 1986 to that in 1991?
Offer a very short reply. 0.82. What is the ratio of the Number of enrolments of both sexes in Austria in 1987 to that in 1988?
Give a very brief answer. 0.98. What is the ratio of the Number of enrolments of both sexes in Burkina Faso in 1987 to that in 1988?
Provide a short and direct response. 0.95. What is the ratio of the Number of enrolments of both sexes in Italy in 1987 to that in 1988?
Give a very brief answer. 1.04. What is the ratio of the Number of enrolments of both sexes in Swaziland in 1987 to that in 1988?
Your answer should be very brief. 0.97. What is the ratio of the Number of enrolments of both sexes in Austria in 1987 to that in 1989?
Offer a terse response. 0.95. What is the ratio of the Number of enrolments of both sexes of Burkina Faso in 1987 to that in 1989?
Keep it short and to the point. 0.88. What is the ratio of the Number of enrolments of both sexes of Italy in 1987 to that in 1989?
Provide a succinct answer. 1.09. What is the ratio of the Number of enrolments of both sexes of Swaziland in 1987 to that in 1989?
Give a very brief answer. 0.94. What is the ratio of the Number of enrolments of both sexes in Austria in 1987 to that in 1990?
Provide a succinct answer. 0.93. What is the ratio of the Number of enrolments of both sexes of Burkina Faso in 1987 to that in 1990?
Provide a succinct answer. 0.83. What is the ratio of the Number of enrolments of both sexes of Italy in 1987 to that in 1990?
Give a very brief answer. 1.12. What is the ratio of the Number of enrolments of both sexes in Swaziland in 1987 to that in 1990?
Your answer should be compact. 0.89. What is the ratio of the Number of enrolments of both sexes of Austria in 1987 to that in 1991?
Your response must be concise. 0.93. What is the ratio of the Number of enrolments of both sexes in Burkina Faso in 1987 to that in 1991?
Give a very brief answer. 0.77. What is the ratio of the Number of enrolments of both sexes in Italy in 1987 to that in 1991?
Your answer should be compact. 1.15. What is the ratio of the Number of enrolments of both sexes in Swaziland in 1987 to that in 1991?
Provide a succinct answer. 0.85. What is the ratio of the Number of enrolments of both sexes in Austria in 1988 to that in 1989?
Your response must be concise. 0.97. What is the ratio of the Number of enrolments of both sexes of Burkina Faso in 1988 to that in 1989?
Make the answer very short. 0.93. What is the ratio of the Number of enrolments of both sexes in Italy in 1988 to that in 1989?
Provide a succinct answer. 1.04. What is the ratio of the Number of enrolments of both sexes of Swaziland in 1988 to that in 1989?
Your answer should be compact. 0.97. What is the ratio of the Number of enrolments of both sexes in Austria in 1988 to that in 1990?
Offer a terse response. 0.96. What is the ratio of the Number of enrolments of both sexes in Burkina Faso in 1988 to that in 1990?
Provide a succinct answer. 0.87. What is the ratio of the Number of enrolments of both sexes of Italy in 1988 to that in 1990?
Keep it short and to the point. 1.07. What is the ratio of the Number of enrolments of both sexes of Swaziland in 1988 to that in 1990?
Your response must be concise. 0.92. What is the ratio of the Number of enrolments of both sexes in Austria in 1988 to that in 1991?
Ensure brevity in your answer.  0.95. What is the ratio of the Number of enrolments of both sexes of Burkina Faso in 1988 to that in 1991?
Give a very brief answer. 0.82. What is the ratio of the Number of enrolments of both sexes of Italy in 1988 to that in 1991?
Make the answer very short. 1.1. What is the ratio of the Number of enrolments of both sexes in Swaziland in 1988 to that in 1991?
Your answer should be compact. 0.88. What is the ratio of the Number of enrolments of both sexes in Austria in 1989 to that in 1990?
Provide a short and direct response. 0.98. What is the ratio of the Number of enrolments of both sexes of Burkina Faso in 1989 to that in 1990?
Make the answer very short. 0.94. What is the ratio of the Number of enrolments of both sexes of Italy in 1989 to that in 1990?
Offer a terse response. 1.03. What is the ratio of the Number of enrolments of both sexes of Swaziland in 1989 to that in 1990?
Keep it short and to the point. 0.95. What is the ratio of the Number of enrolments of both sexes of Austria in 1989 to that in 1991?
Make the answer very short. 0.97. What is the ratio of the Number of enrolments of both sexes of Burkina Faso in 1989 to that in 1991?
Your answer should be very brief. 0.88. What is the ratio of the Number of enrolments of both sexes in Italy in 1989 to that in 1991?
Your answer should be compact. 1.06. What is the ratio of the Number of enrolments of both sexes in Swaziland in 1989 to that in 1991?
Keep it short and to the point. 0.91. What is the ratio of the Number of enrolments of both sexes in Burkina Faso in 1990 to that in 1991?
Keep it short and to the point. 0.94. What is the ratio of the Number of enrolments of both sexes of Italy in 1990 to that in 1991?
Give a very brief answer. 1.03. What is the ratio of the Number of enrolments of both sexes of Swaziland in 1990 to that in 1991?
Give a very brief answer. 0.96. What is the difference between the highest and the second highest Number of enrolments of both sexes of Austria?
Your answer should be very brief. 3204. What is the difference between the highest and the second highest Number of enrolments of both sexes of Burkina Faso?
Provide a succinct answer. 3.14e+04. What is the difference between the highest and the second highest Number of enrolments of both sexes of Italy?
Your response must be concise. 2.01e+05. What is the difference between the highest and the second highest Number of enrolments of both sexes in Swaziland?
Your answer should be compact. 6454. What is the difference between the highest and the lowest Number of enrolments of both sexes of Austria?
Your answer should be compact. 2.74e+04. What is the difference between the highest and the lowest Number of enrolments of both sexes of Burkina Faso?
Offer a very short reply. 1.91e+05. What is the difference between the highest and the lowest Number of enrolments of both sexes in Italy?
Keep it short and to the point. 8.48e+05. What is the difference between the highest and the lowest Number of enrolments of both sexes of Swaziland?
Your answer should be very brief. 3.36e+04. 